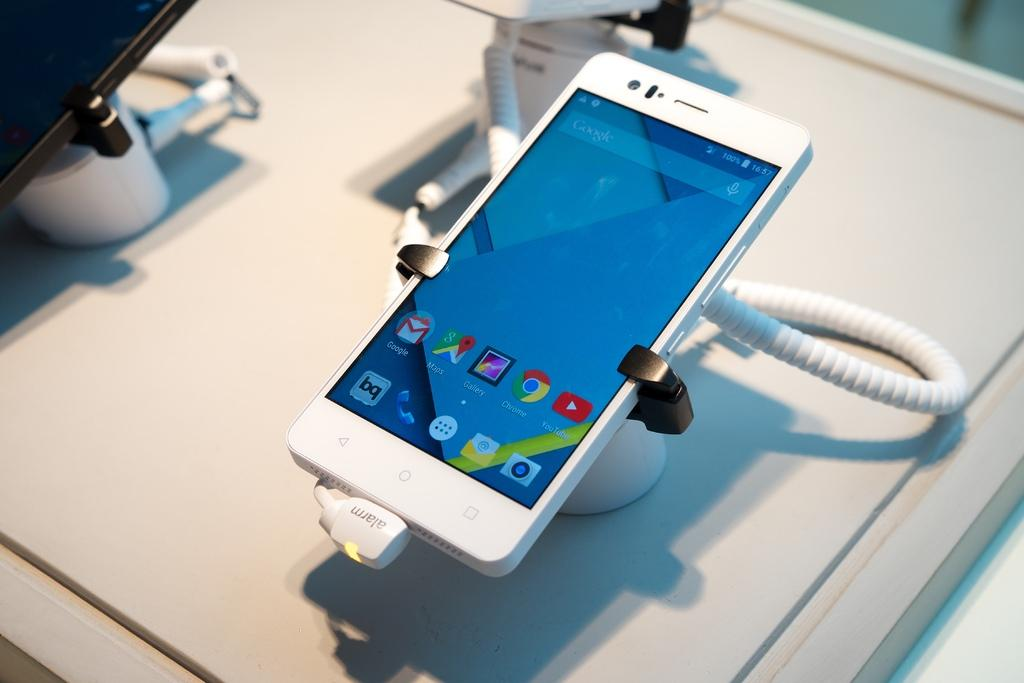<image>
Present a compact description of the photo's key features. Small white phone on display at a store with the time set at 16:57. 